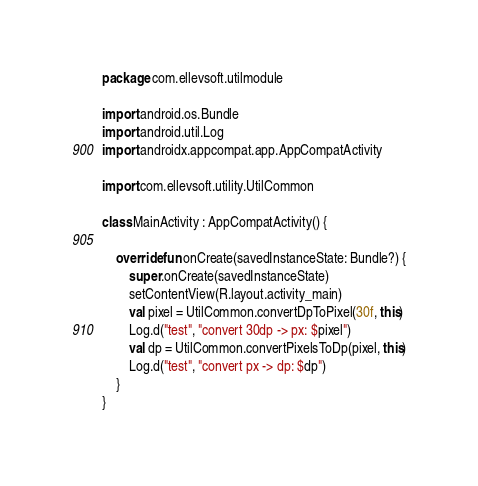<code> <loc_0><loc_0><loc_500><loc_500><_Kotlin_>package com.ellevsoft.utilmodule

import android.os.Bundle
import android.util.Log
import androidx.appcompat.app.AppCompatActivity

import com.ellevsoft.utility.UtilCommon

class MainActivity : AppCompatActivity() {

    override fun onCreate(savedInstanceState: Bundle?) {
        super.onCreate(savedInstanceState)
        setContentView(R.layout.activity_main)
        val pixel = UtilCommon.convertDpToPixel(30f, this)
        Log.d("test", "convert 30dp -> px: $pixel")
        val dp = UtilCommon.convertPixelsToDp(pixel, this)
        Log.d("test", "convert px -> dp: $dp")
    }
}
</code> 